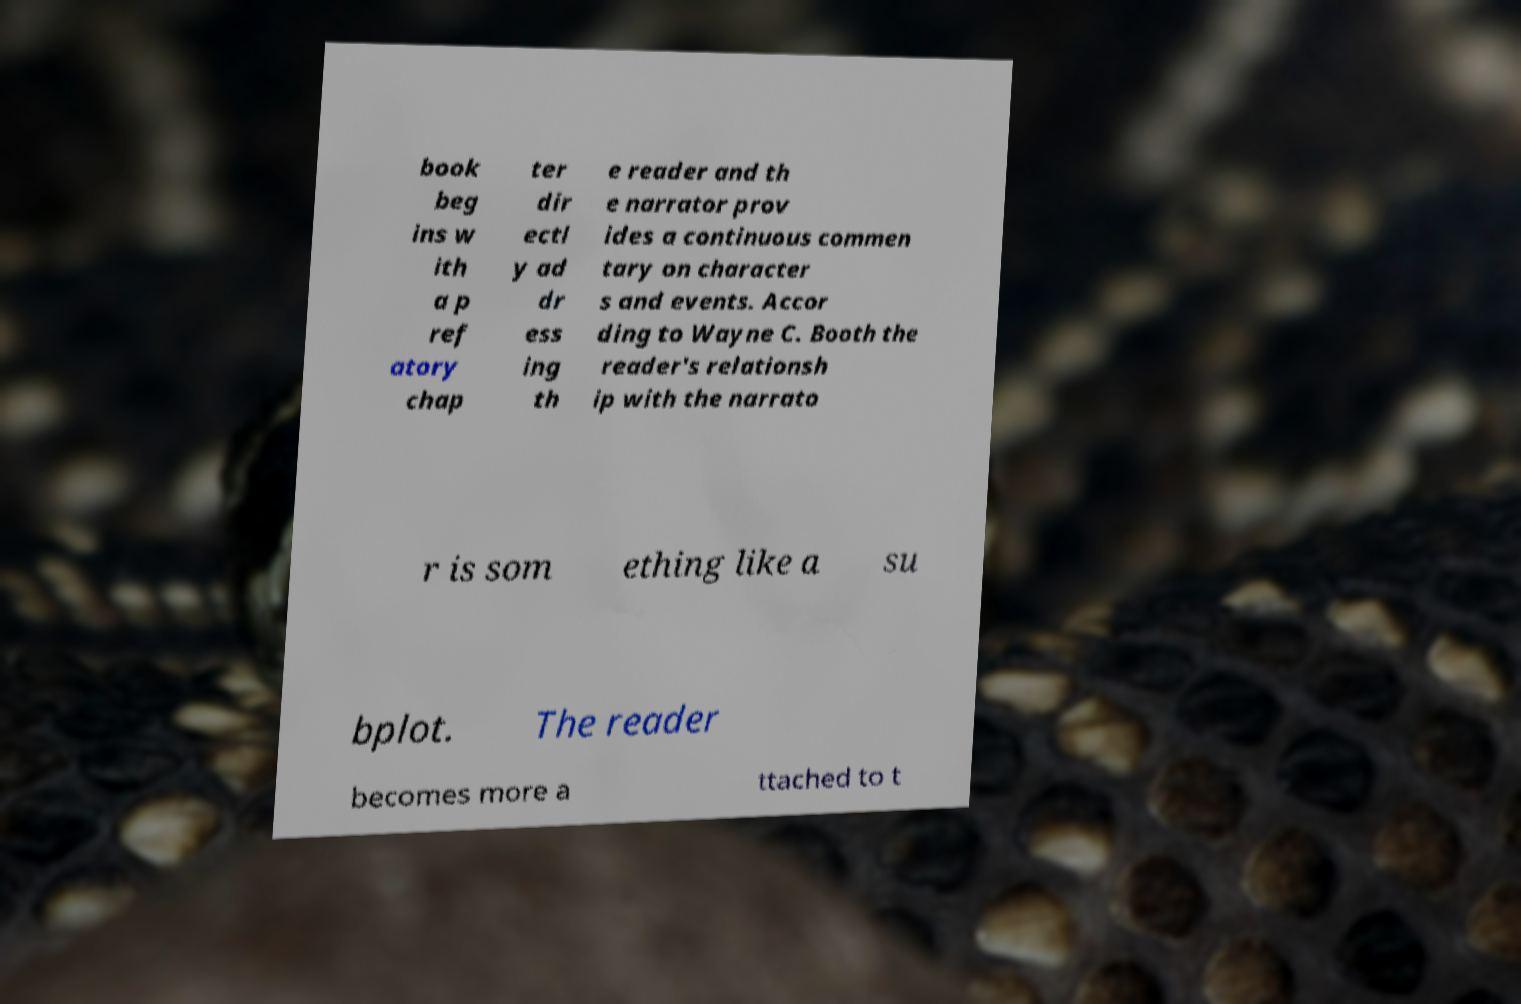Could you assist in decoding the text presented in this image and type it out clearly? book beg ins w ith a p ref atory chap ter dir ectl y ad dr ess ing th e reader and th e narrator prov ides a continuous commen tary on character s and events. Accor ding to Wayne C. Booth the reader's relationsh ip with the narrato r is som ething like a su bplot. The reader becomes more a ttached to t 